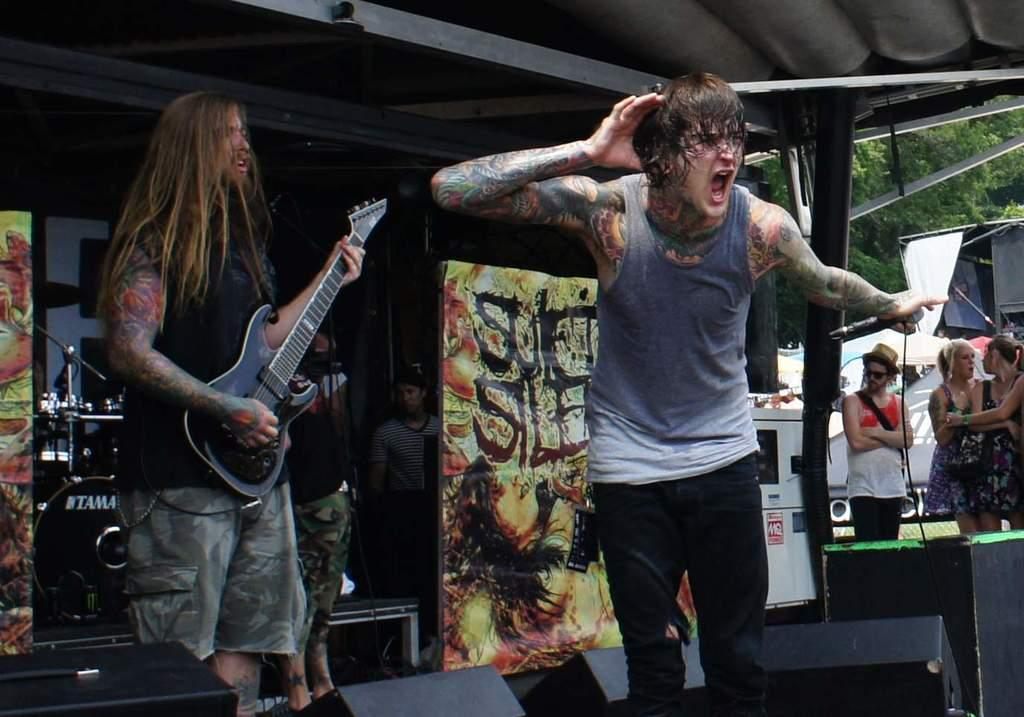What is the man in the image doing? The man in the image is singing. Where is the man singing located? The man is singing on a dais. What instrument is being played in the image? There is a man playing a guitar in the image. How is the guitar-playing man positioned in relation to the singing man? The guitar-playing man is standing back off the singing man. Can you see the thumb of the cat in the image? There is no cat present in the image, and therefore no thumb can be seen. 